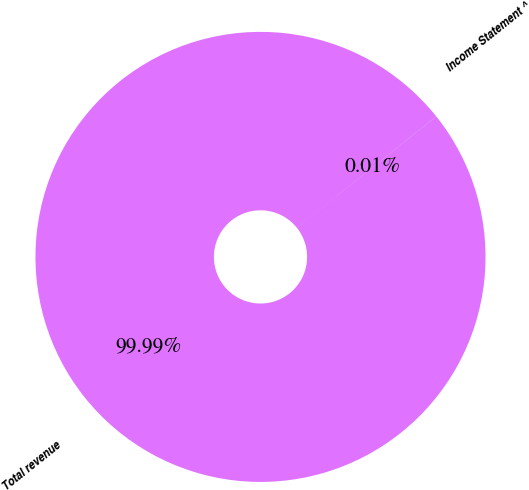Convert chart to OTSL. <chart><loc_0><loc_0><loc_500><loc_500><pie_chart><fcel>Income Statement ^<fcel>Total revenue<nl><fcel>0.01%<fcel>99.99%<nl></chart> 